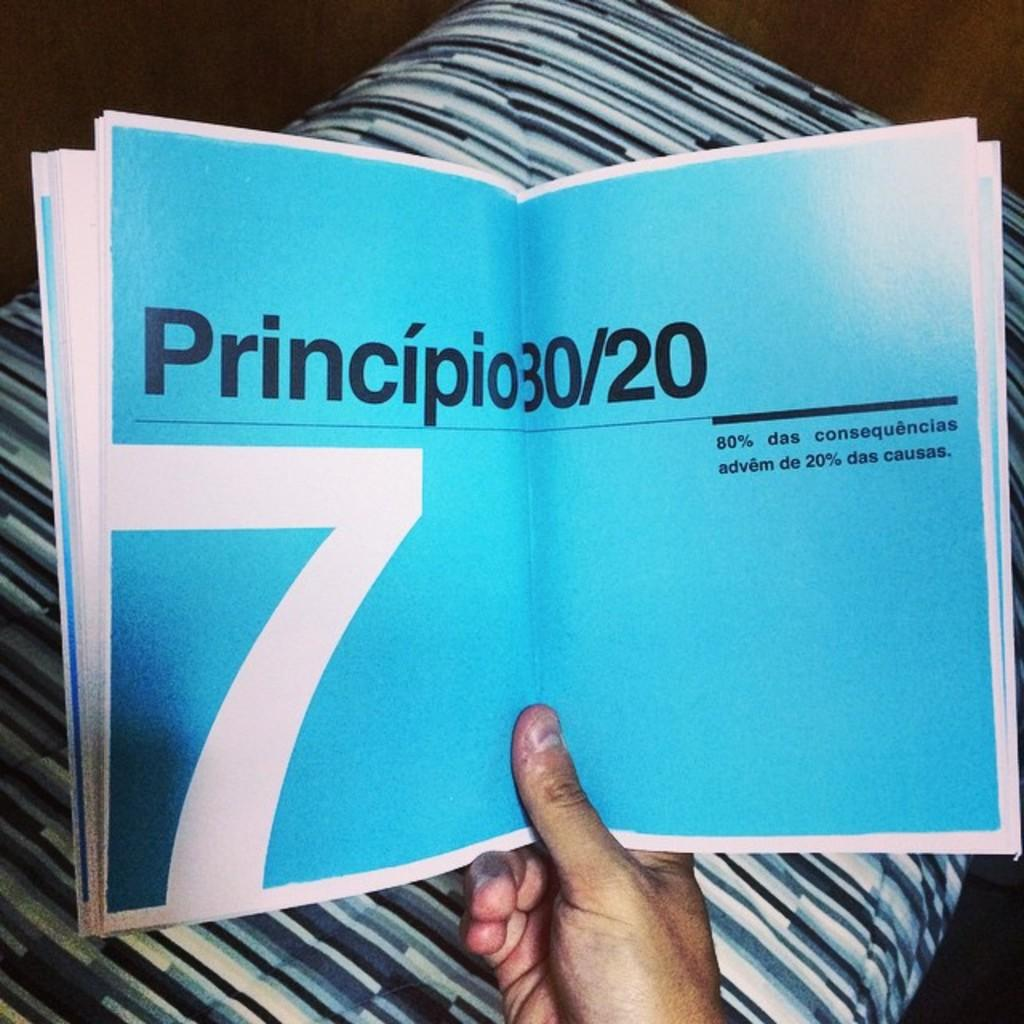<image>
Offer a succinct explanation of the picture presented. A book is opened to blue pages with black text that says "Principio 30/20." 